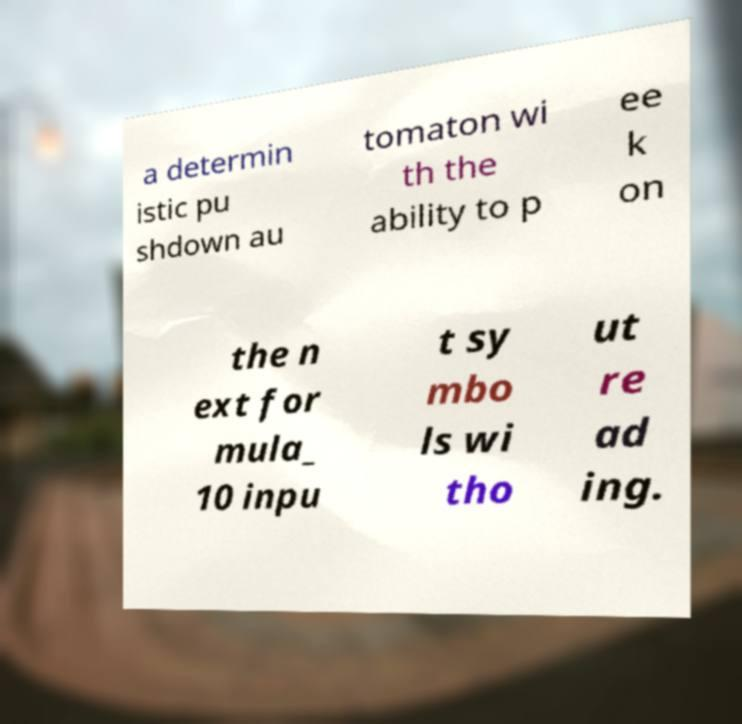What messages or text are displayed in this image? I need them in a readable, typed format. a determin istic pu shdown au tomaton wi th the ability to p ee k on the n ext for mula_ 10 inpu t sy mbo ls wi tho ut re ad ing. 